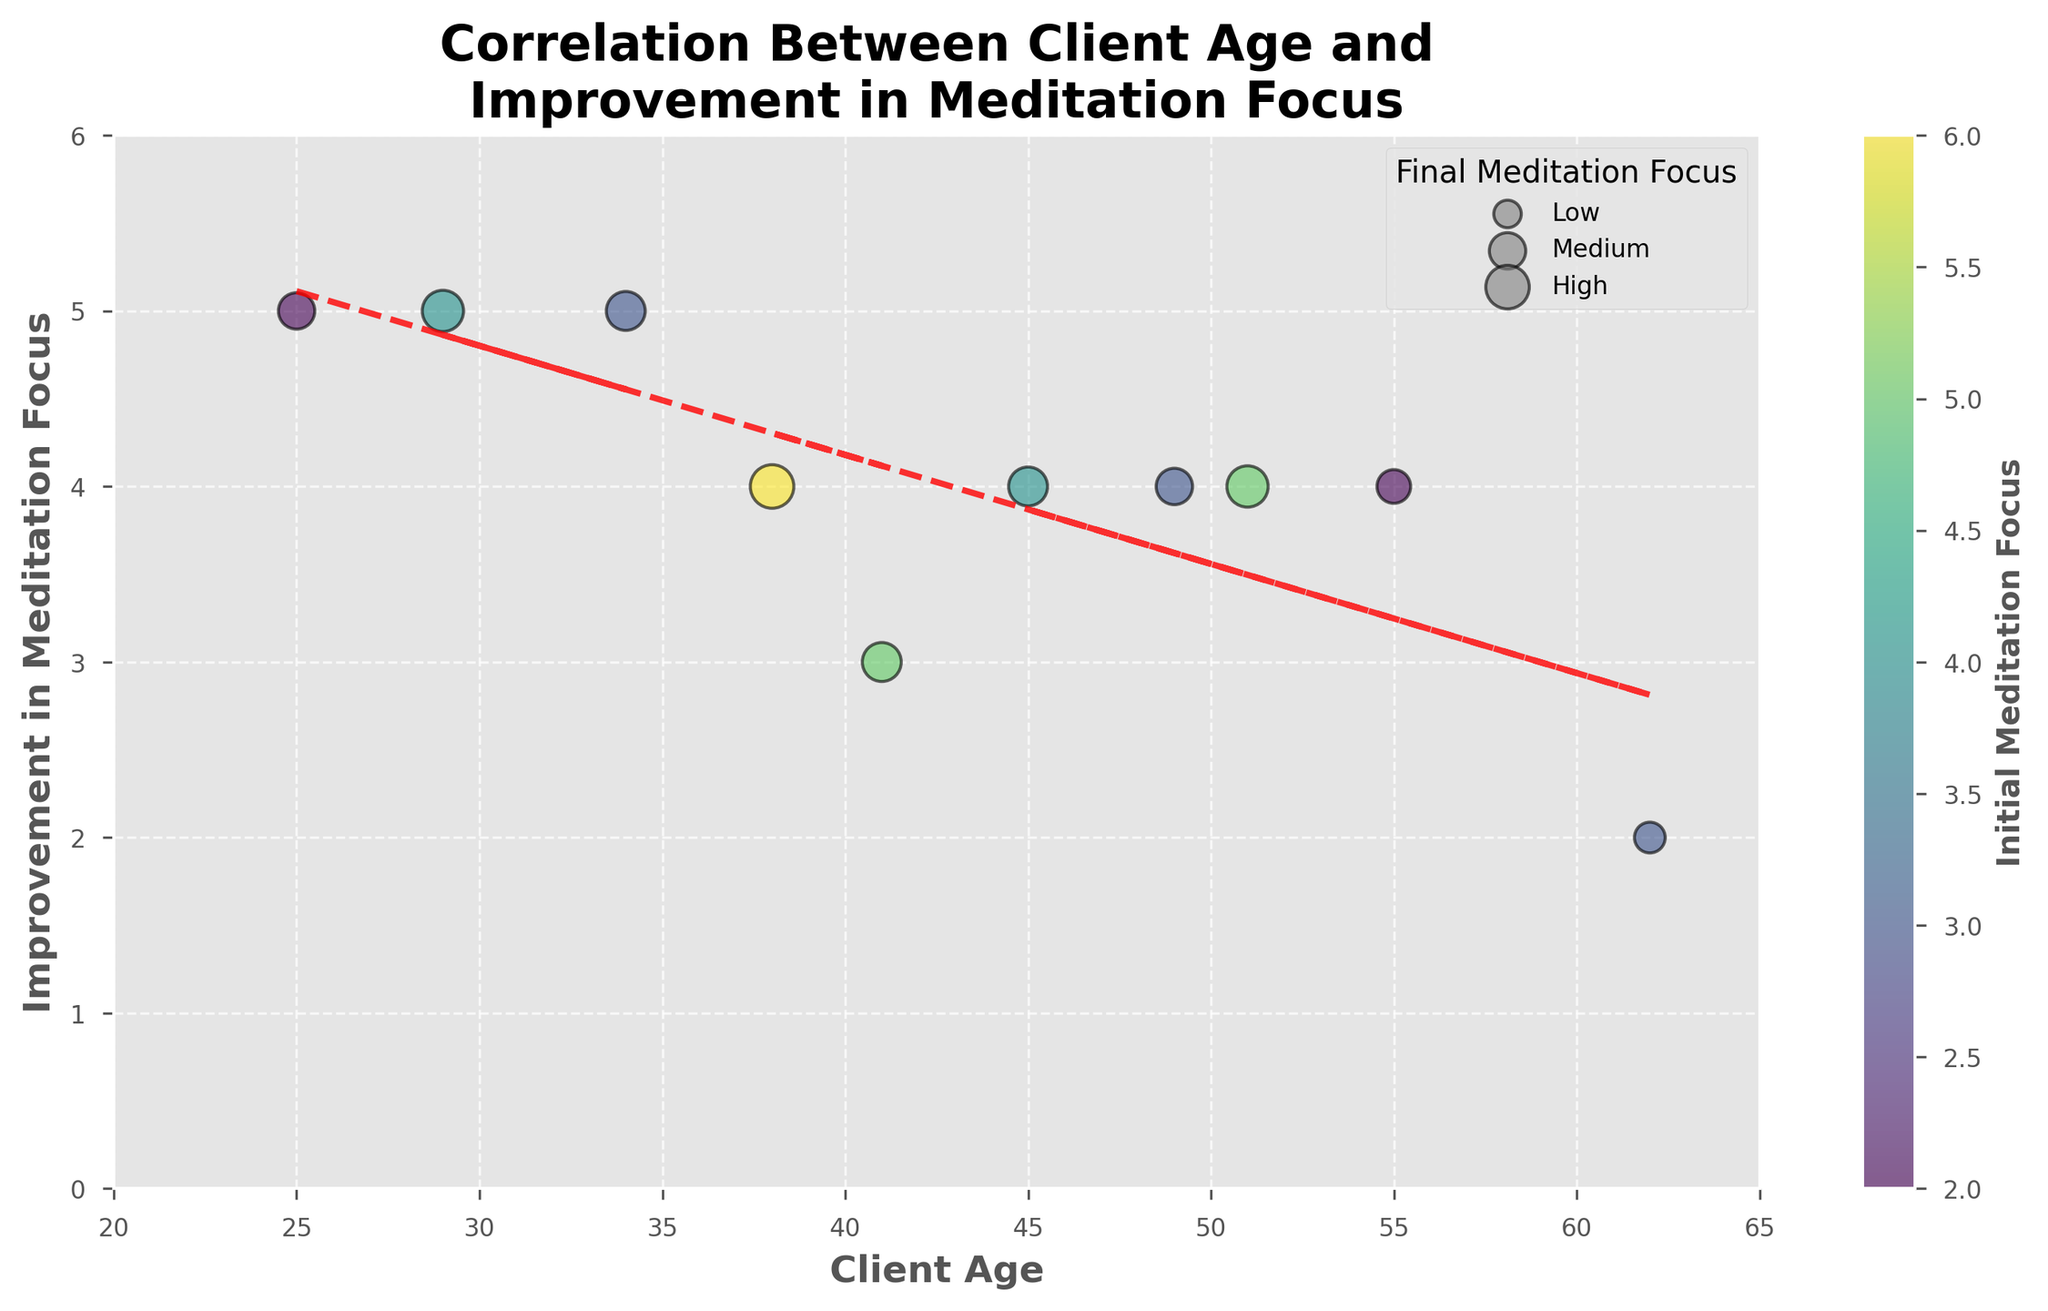What is the title of the figure? The title is usually placed at the top center of the chart. It provides a summary of what the chart represents. In this case, it indicates the relationship between two variables.
Answer: Correlation Between Client Age and Improvement in Meditation Focus What are the axes labels in the figure? The axes labels describe the data plotted along the x-axis and y-axis. The x-axis is labeled "Client Age," and the y-axis is labeled "Improvement in Meditation Focus."
Answer: Client Age; Improvement in Meditation Focus How many data points are displayed in the scatter plot? Each data point on the scatter plot represents an individual client. Counting the number of points gives the total number of clients.
Answer: 10 What is the trend displayed by the trend line in the chart? The trend line represents the general direction of the data points. By observing the slope of the trend line, we can determine whether it is increasing or decreasing.
Answer: Slightly decreasing Which age group shows the lowest improvement in meditation focus? To determine this, we need to find the data point with the lowest value on the y-axis and check the corresponding age on the x-axis. The color and size of the bubble will also assist in the visualization.
Answer: Around 62 years old (Client 8) What is the initial meditation focus of the client who has the highest improvement in meditation focus? To find this, we identify the data point with the highest value on the y-axis. Then, check the corresponding color of this data point, as the color represents the initial meditation focus.
Answer: 2 (Clients 1, 2, 3) How does the improvement in meditation focus change with age for clients between 40 and 50 years old? Observing the data points and the trend line between the ages of 40 and 50 allows us to see the pattern of improvement in focus within this age range. We look for any apparent increase or decrease.
Answer: Improvement mostly stays around 3-4 Which client shows a medium final meditation focus and what is their age? A medium final meditation focus is around 7-8, represented by the size of the bubble. We look for a bubble of medium size and check the corresponding age on the x-axis.
Answer: 41 years old (Client 4) Is there a visible correlation between initial meditation focus and improvement in meditation focus? To find the correlation, observe the color gradient of the bubbles. If higher improvement is often associated with certain colors, there could be a correlation between the initial focus and improvement.
Answer: No strong visible correlation What does the colorbar to the right of the figure represent? The colorbar is a visual aid that indicates the range of values represented by different colors on the scatter plot. Each color corresponds to a level of initial meditation focus.
Answer: Initial Meditation Focus 